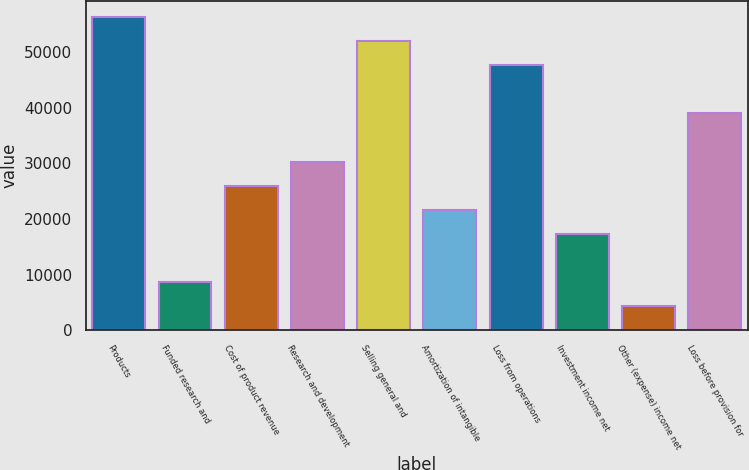Convert chart. <chart><loc_0><loc_0><loc_500><loc_500><bar_chart><fcel>Products<fcel>Funded research and<fcel>Cost of product revenue<fcel>Research and development<fcel>Selling general and<fcel>Amortization of intangible<fcel>Loss from operations<fcel>Investment income net<fcel>Other (expense) income net<fcel>Loss before provision for<nl><fcel>56318.2<fcel>8665.31<fcel>25993.7<fcel>30325.8<fcel>51986.2<fcel>21661.6<fcel>47654.1<fcel>17329.5<fcel>4333.23<fcel>38989.9<nl></chart> 